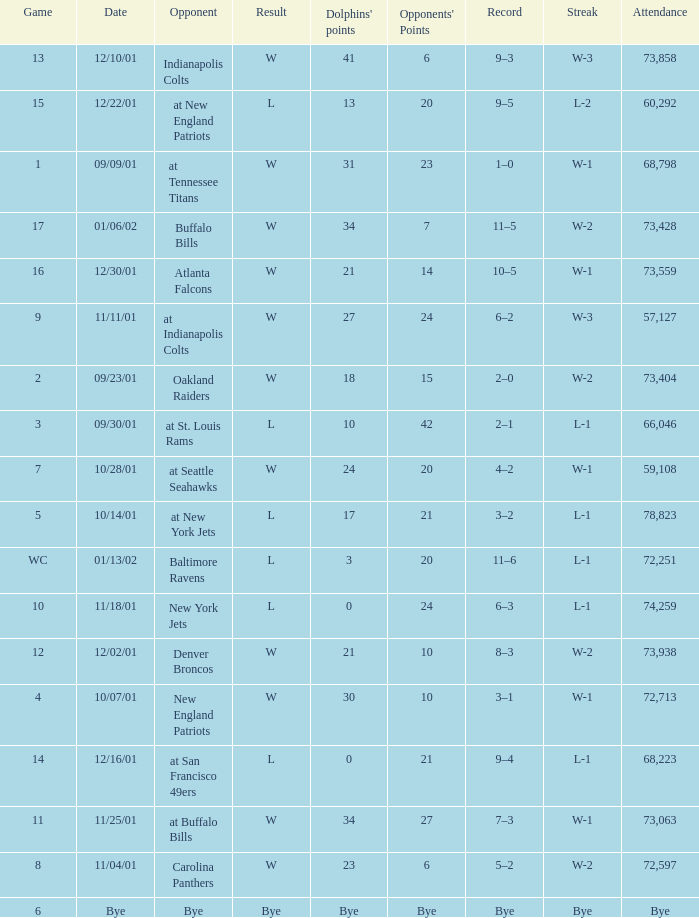What was the attendance of the Oakland Raiders game? 73404.0. Help me parse the entirety of this table. {'header': ['Game', 'Date', 'Opponent', 'Result', "Dolphins' points", "Opponents' Points", 'Record', 'Streak', 'Attendance'], 'rows': [['13', '12/10/01', 'Indianapolis Colts', 'W', '41', '6', '9–3', 'W-3', '73,858'], ['15', '12/22/01', 'at New England Patriots', 'L', '13', '20', '9–5', 'L-2', '60,292'], ['1', '09/09/01', 'at Tennessee Titans', 'W', '31', '23', '1–0', 'W-1', '68,798'], ['17', '01/06/02', 'Buffalo Bills', 'W', '34', '7', '11–5', 'W-2', '73,428'], ['16', '12/30/01', 'Atlanta Falcons', 'W', '21', '14', '10–5', 'W-1', '73,559'], ['9', '11/11/01', 'at Indianapolis Colts', 'W', '27', '24', '6–2', 'W-3', '57,127'], ['2', '09/23/01', 'Oakland Raiders', 'W', '18', '15', '2–0', 'W-2', '73,404'], ['3', '09/30/01', 'at St. Louis Rams', 'L', '10', '42', '2–1', 'L-1', '66,046'], ['7', '10/28/01', 'at Seattle Seahawks', 'W', '24', '20', '4–2', 'W-1', '59,108'], ['5', '10/14/01', 'at New York Jets', 'L', '17', '21', '3–2', 'L-1', '78,823'], ['WC', '01/13/02', 'Baltimore Ravens', 'L', '3', '20', '11–6', 'L-1', '72,251'], ['10', '11/18/01', 'New York Jets', 'L', '0', '24', '6–3', 'L-1', '74,259'], ['12', '12/02/01', 'Denver Broncos', 'W', '21', '10', '8–3', 'W-2', '73,938'], ['4', '10/07/01', 'New England Patriots', 'W', '30', '10', '3–1', 'W-1', '72,713'], ['14', '12/16/01', 'at San Francisco 49ers', 'L', '0', '21', '9–4', 'L-1', '68,223'], ['11', '11/25/01', 'at Buffalo Bills', 'W', '34', '27', '7–3', 'W-1', '73,063'], ['8', '11/04/01', 'Carolina Panthers', 'W', '23', '6', '5–2', 'W-2', '72,597'], ['6', 'Bye', 'Bye', 'Bye', 'Bye', 'Bye', 'Bye', 'Bye', 'Bye']]} 